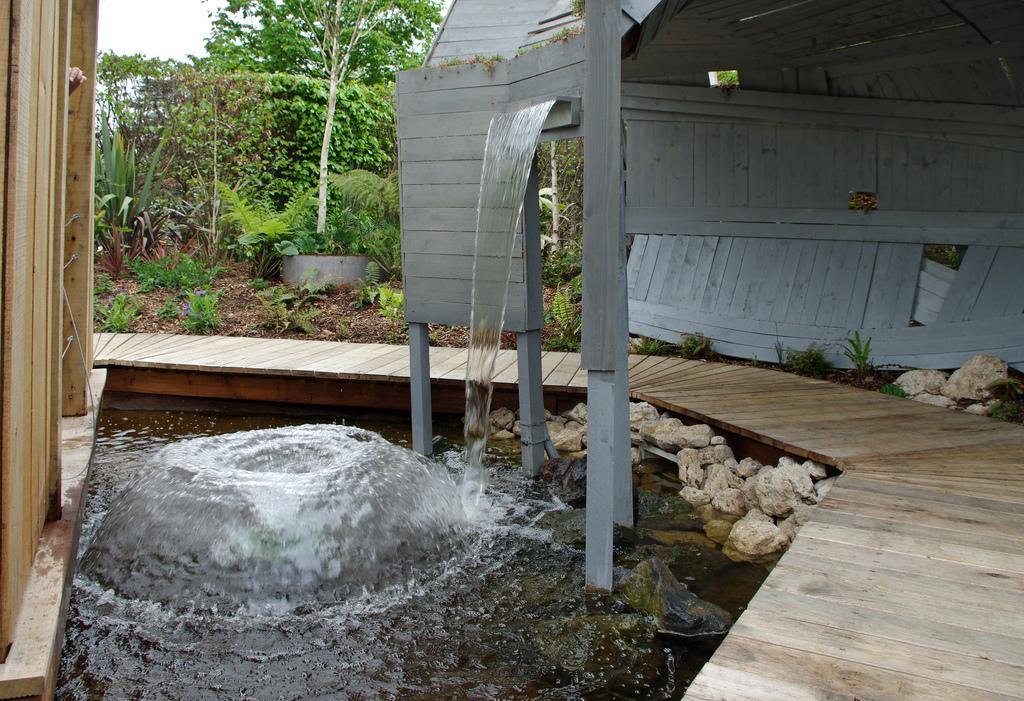Could you give a brief overview of what you see in this image? On the left and right sides of the image there are some wooden planks. At the bottom I can see the water. In the background there are some plants and also there are some metal boards. 